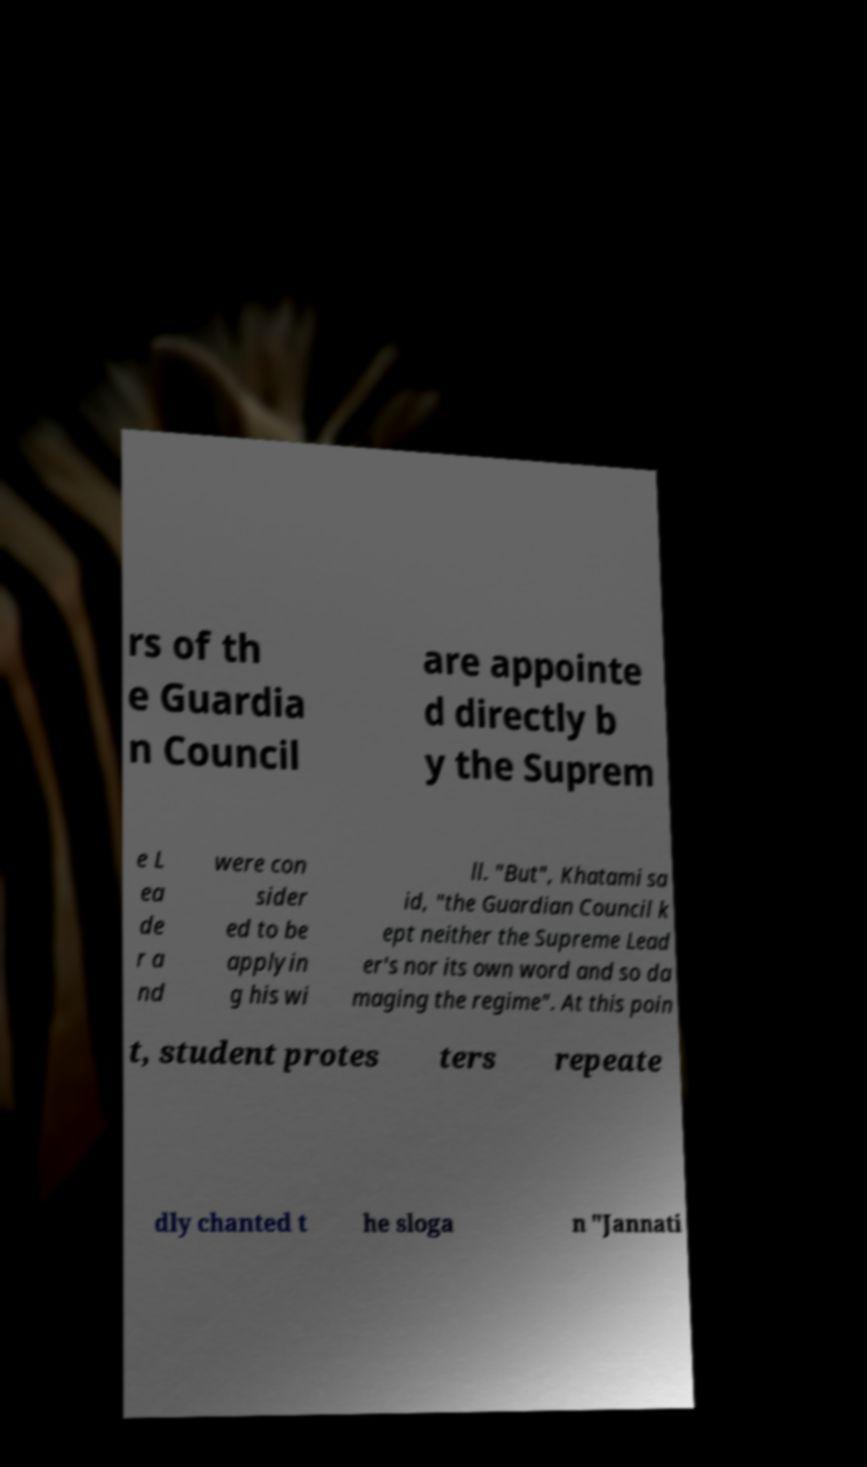What messages or text are displayed in this image? I need them in a readable, typed format. rs of th e Guardia n Council are appointe d directly b y the Suprem e L ea de r a nd were con sider ed to be applyin g his wi ll. "But", Khatami sa id, "the Guardian Council k ept neither the Supreme Lead er's nor its own word and so da maging the regime". At this poin t, student protes ters repeate dly chanted t he sloga n "Jannati 